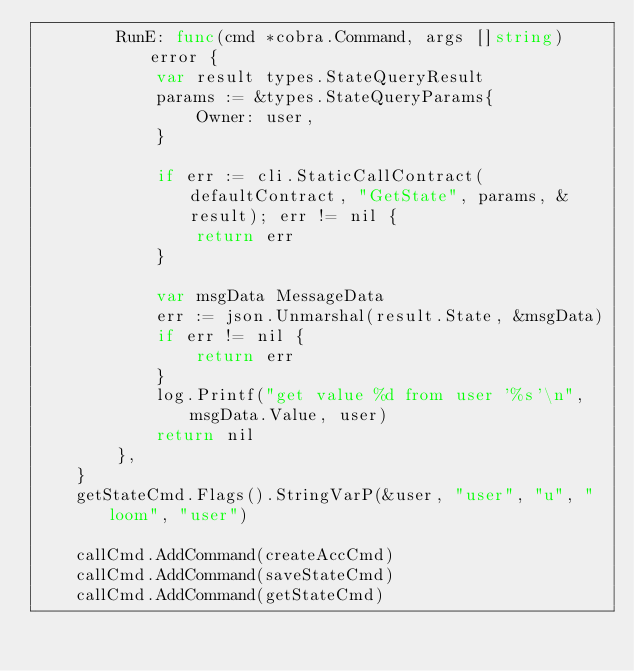Convert code to text. <code><loc_0><loc_0><loc_500><loc_500><_Go_>		RunE: func(cmd *cobra.Command, args []string) error {
			var result types.StateQueryResult
			params := &types.StateQueryParams{
				Owner: user,
			}

			if err := cli.StaticCallContract(defaultContract, "GetState", params, &result); err != nil {
				return err
			}

			var msgData MessageData
			err := json.Unmarshal(result.State, &msgData)
			if err != nil {
				return err
			}
			log.Printf("get value %d from user '%s'\n", msgData.Value, user)
			return nil
		},
	}
	getStateCmd.Flags().StringVarP(&user, "user", "u", "loom", "user")

	callCmd.AddCommand(createAccCmd)
	callCmd.AddCommand(saveStateCmd)
	callCmd.AddCommand(getStateCmd)
</code> 